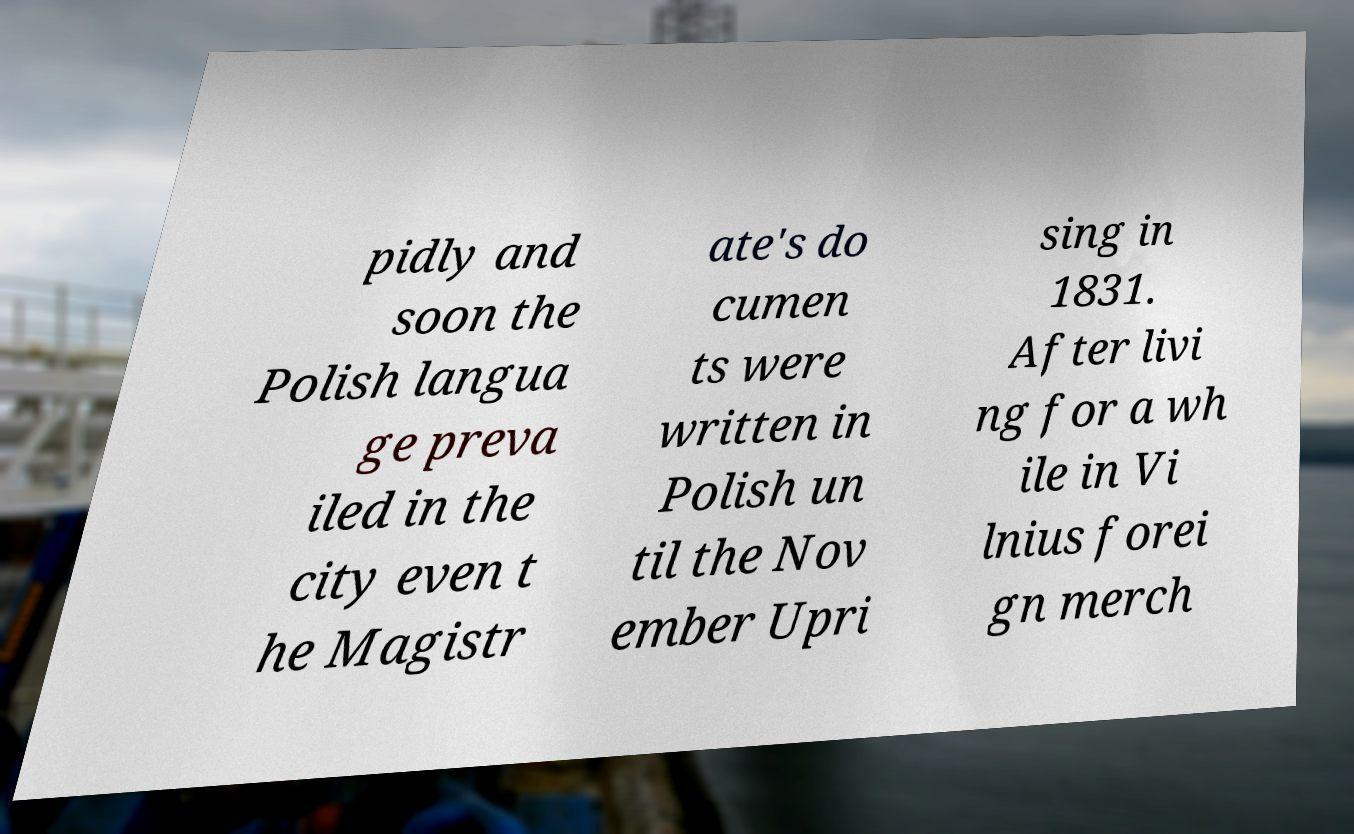Could you extract and type out the text from this image? pidly and soon the Polish langua ge preva iled in the city even t he Magistr ate's do cumen ts were written in Polish un til the Nov ember Upri sing in 1831. After livi ng for a wh ile in Vi lnius forei gn merch 